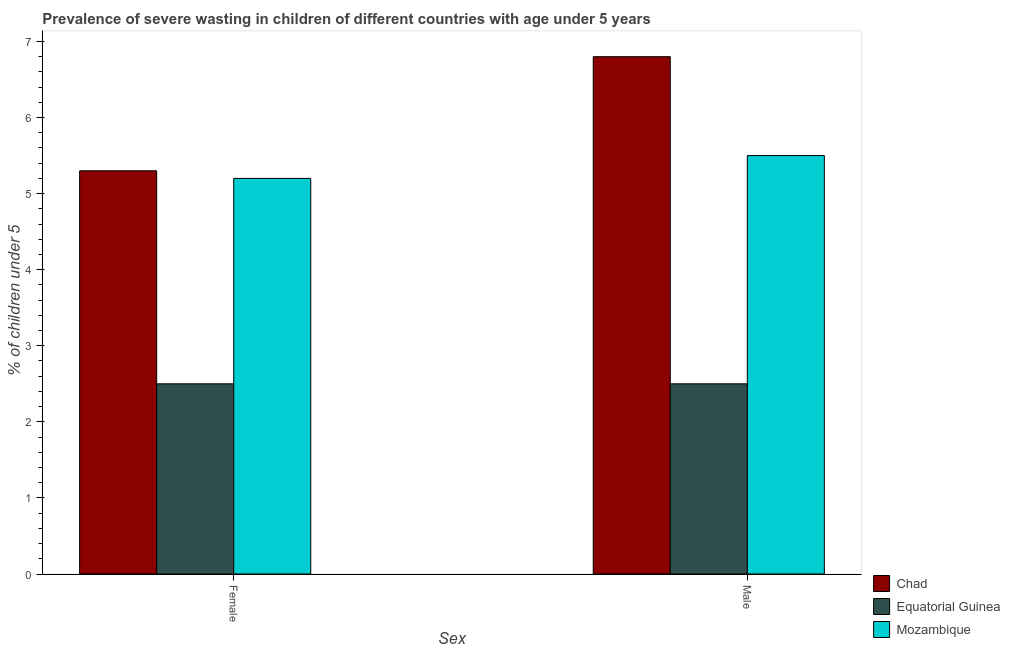How many different coloured bars are there?
Offer a terse response. 3. How many groups of bars are there?
Offer a very short reply. 2. Are the number of bars per tick equal to the number of legend labels?
Your response must be concise. Yes. Are the number of bars on each tick of the X-axis equal?
Give a very brief answer. Yes. How many bars are there on the 2nd tick from the left?
Offer a very short reply. 3. Across all countries, what is the maximum percentage of undernourished male children?
Give a very brief answer. 6.8. In which country was the percentage of undernourished male children maximum?
Provide a succinct answer. Chad. In which country was the percentage of undernourished male children minimum?
Keep it short and to the point. Equatorial Guinea. What is the total percentage of undernourished male children in the graph?
Your answer should be very brief. 14.8. What is the difference between the percentage of undernourished female children in Mozambique and the percentage of undernourished male children in Equatorial Guinea?
Your answer should be compact. 2.7. What is the average percentage of undernourished female children per country?
Keep it short and to the point. 4.33. What is the ratio of the percentage of undernourished female children in Chad to that in Equatorial Guinea?
Keep it short and to the point. 2.12. What does the 3rd bar from the left in Female represents?
Ensure brevity in your answer.  Mozambique. What does the 1st bar from the right in Female represents?
Make the answer very short. Mozambique. Are all the bars in the graph horizontal?
Your answer should be compact. No. How many countries are there in the graph?
Offer a terse response. 3. What is the difference between two consecutive major ticks on the Y-axis?
Your answer should be compact. 1. Are the values on the major ticks of Y-axis written in scientific E-notation?
Your answer should be very brief. No. Does the graph contain grids?
Offer a terse response. No. How many legend labels are there?
Make the answer very short. 3. What is the title of the graph?
Your answer should be very brief. Prevalence of severe wasting in children of different countries with age under 5 years. What is the label or title of the X-axis?
Your answer should be compact. Sex. What is the label or title of the Y-axis?
Your answer should be very brief.  % of children under 5. What is the  % of children under 5 in Chad in Female?
Your answer should be very brief. 5.3. What is the  % of children under 5 of Equatorial Guinea in Female?
Provide a succinct answer. 2.5. What is the  % of children under 5 of Mozambique in Female?
Give a very brief answer. 5.2. What is the  % of children under 5 of Chad in Male?
Give a very brief answer. 6.8. What is the  % of children under 5 in Equatorial Guinea in Male?
Offer a very short reply. 2.5. Across all Sex, what is the maximum  % of children under 5 of Chad?
Ensure brevity in your answer.  6.8. Across all Sex, what is the minimum  % of children under 5 of Chad?
Ensure brevity in your answer.  5.3. Across all Sex, what is the minimum  % of children under 5 in Equatorial Guinea?
Your answer should be very brief. 2.5. Across all Sex, what is the minimum  % of children under 5 in Mozambique?
Your answer should be very brief. 5.2. What is the total  % of children under 5 in Chad in the graph?
Ensure brevity in your answer.  12.1. What is the total  % of children under 5 in Equatorial Guinea in the graph?
Give a very brief answer. 5. What is the total  % of children under 5 of Mozambique in the graph?
Make the answer very short. 10.7. What is the difference between the  % of children under 5 of Mozambique in Female and that in Male?
Keep it short and to the point. -0.3. What is the average  % of children under 5 of Chad per Sex?
Give a very brief answer. 6.05. What is the average  % of children under 5 of Equatorial Guinea per Sex?
Offer a very short reply. 2.5. What is the average  % of children under 5 in Mozambique per Sex?
Make the answer very short. 5.35. What is the difference between the  % of children under 5 in Chad and  % of children under 5 in Equatorial Guinea in Female?
Ensure brevity in your answer.  2.8. What is the difference between the  % of children under 5 in Chad and  % of children under 5 in Mozambique in Female?
Give a very brief answer. 0.1. What is the ratio of the  % of children under 5 of Chad in Female to that in Male?
Provide a succinct answer. 0.78. What is the ratio of the  % of children under 5 of Equatorial Guinea in Female to that in Male?
Your answer should be compact. 1. What is the ratio of the  % of children under 5 of Mozambique in Female to that in Male?
Ensure brevity in your answer.  0.95. What is the difference between the highest and the lowest  % of children under 5 of Equatorial Guinea?
Provide a short and direct response. 0. 